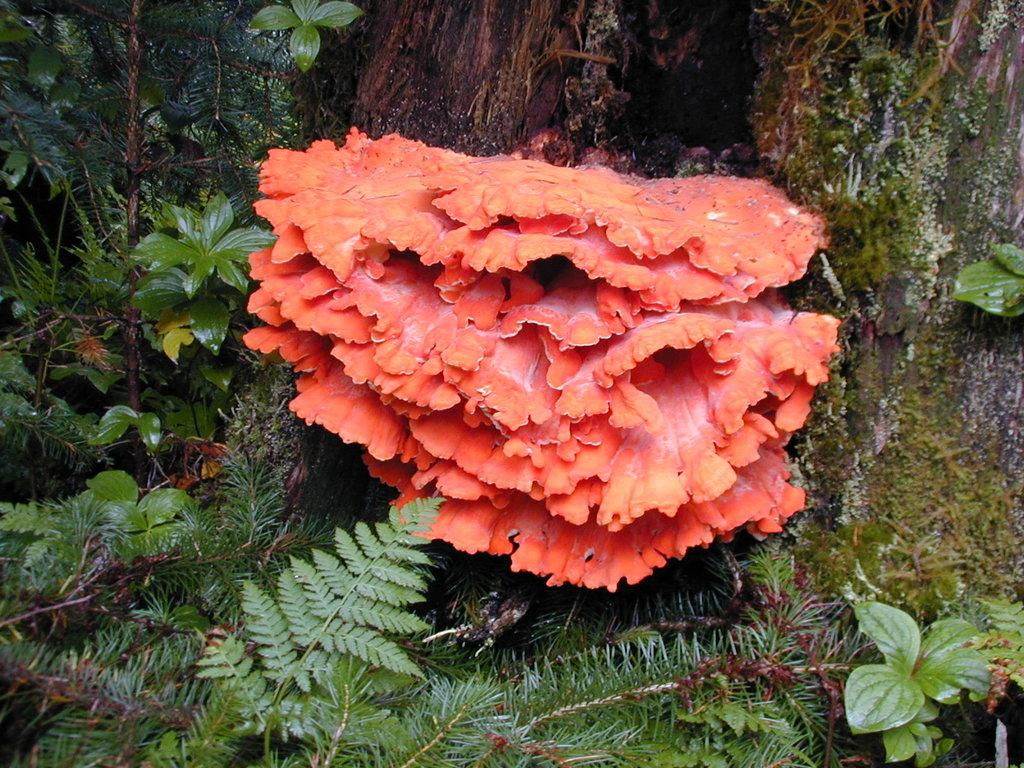What type of living organisms can be seen in the image? Plants can be seen in the image. What type of glove is being worn by the guitar player in the image? There is no guitar player or glove present in the image; it only features plants. 